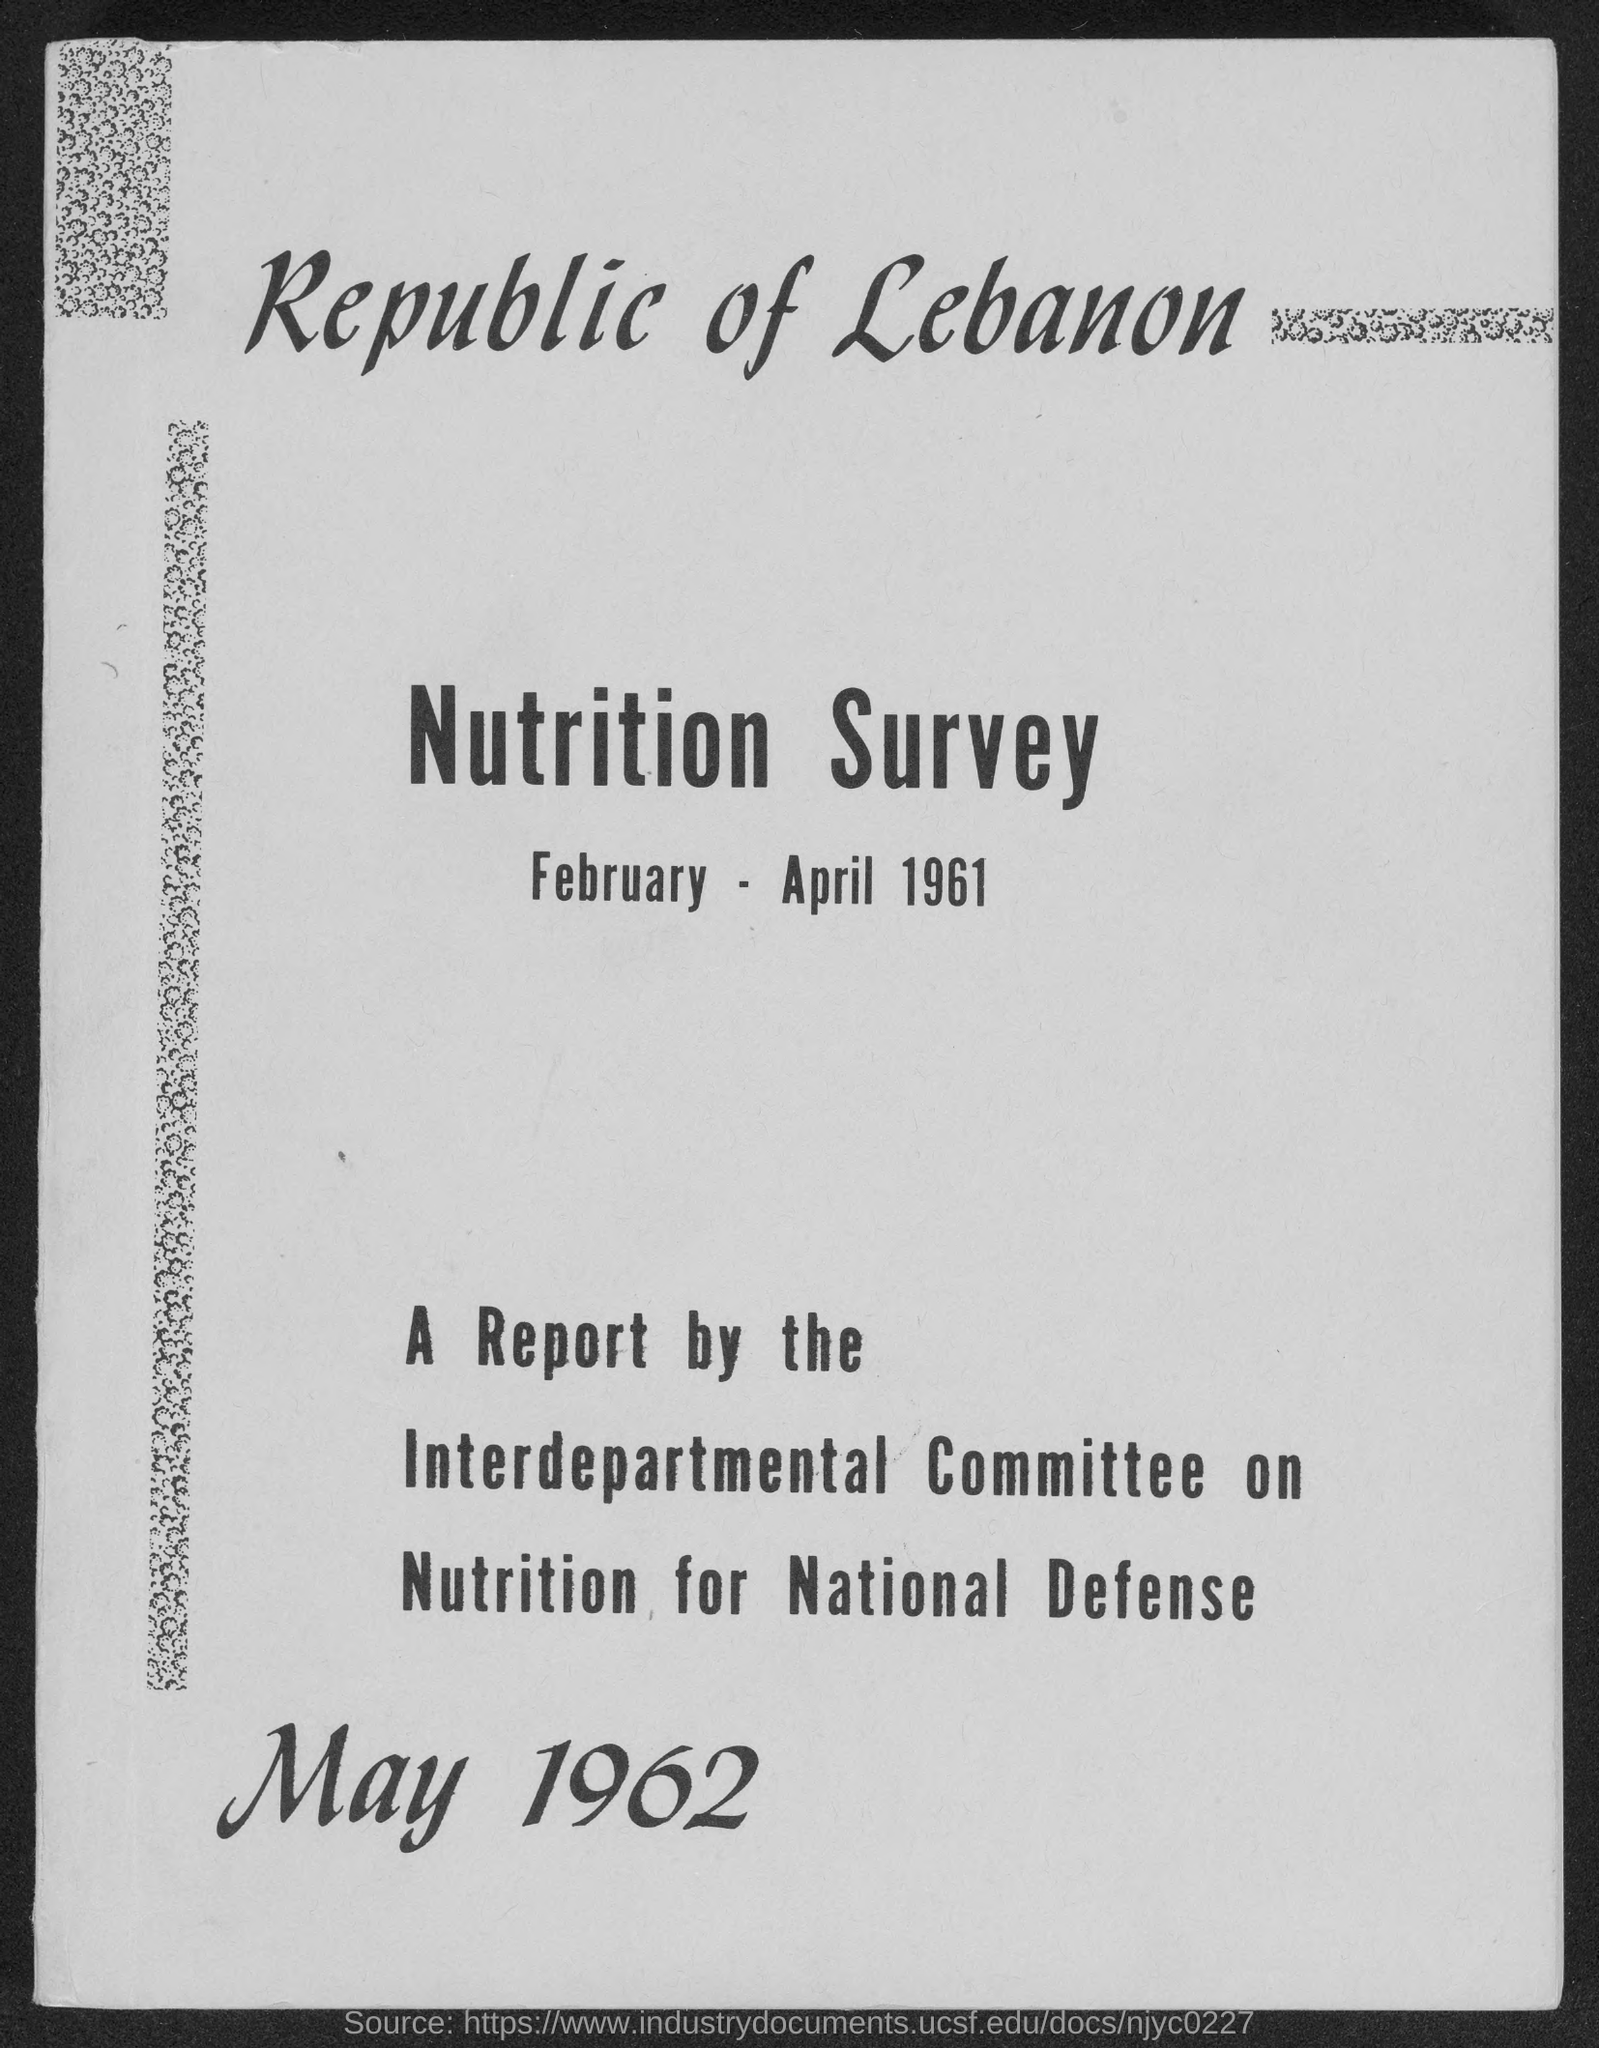Specify some key components in this picture. The date mentioned at the bottom of the document is May 1962. The report was prepared by an interdepartmental committee on nutrition for national defense. The second title in the document is 'nutrition survey.' 